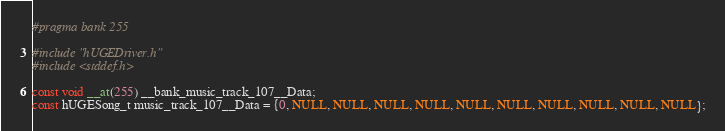<code> <loc_0><loc_0><loc_500><loc_500><_C_>#pragma bank 255

#include "hUGEDriver.h"
#include <stddef.h>

const void __at(255) __bank_music_track_107__Data;
const hUGESong_t music_track_107__Data = {0, NULL, NULL, NULL, NULL, NULL, NULL, NULL, NULL, NULL, NULL};
</code> 